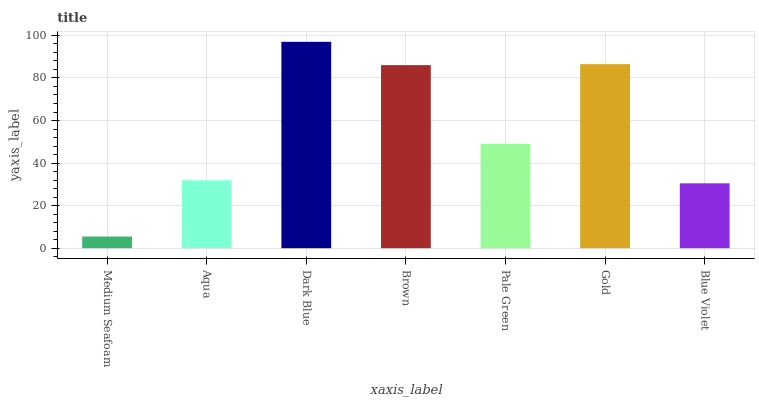Is Medium Seafoam the minimum?
Answer yes or no. Yes. Is Dark Blue the maximum?
Answer yes or no. Yes. Is Aqua the minimum?
Answer yes or no. No. Is Aqua the maximum?
Answer yes or no. No. Is Aqua greater than Medium Seafoam?
Answer yes or no. Yes. Is Medium Seafoam less than Aqua?
Answer yes or no. Yes. Is Medium Seafoam greater than Aqua?
Answer yes or no. No. Is Aqua less than Medium Seafoam?
Answer yes or no. No. Is Pale Green the high median?
Answer yes or no. Yes. Is Pale Green the low median?
Answer yes or no. Yes. Is Blue Violet the high median?
Answer yes or no. No. Is Aqua the low median?
Answer yes or no. No. 